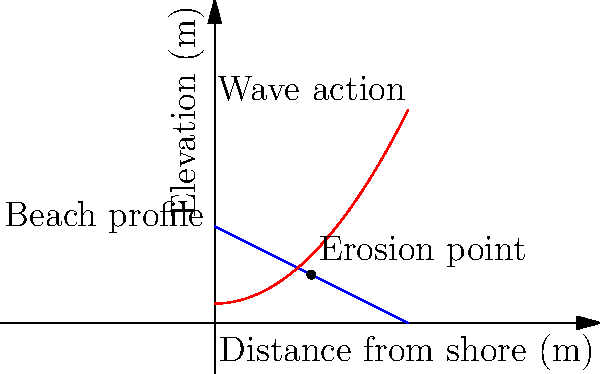As a backpacker exploring Ibiza's hidden beaches, you notice a particular sandy beach experiencing erosion. The beach profile can be approximated by the function $h(x) = 5 - 0.5x$, where $h$ is the elevation in meters and $x$ is the distance from the shore in meters. The wave action can be described by the function $w(x) = 1 + 0.1x^2$. At what distance from the shore does the maximum erosion occur, and what is the erosion rate at this point if the coefficient of erosion is $0.02 \text{ m}^3/\text{year}$ per meter of elevation difference? To solve this problem, we'll follow these steps:

1) The point of maximum erosion occurs where the difference between the beach profile and wave action is greatest.

2) We can find this by equating the derivatives of both functions:

   $\frac{d}{dx}h(x) = -0.5$
   $\frac{d}{dx}w(x) = 0.2x$

3) Equating these:
   $-0.5 = 0.2x$
   $x = -\frac{0.5}{0.2} = -2.5$

4) However, x cannot be negative in this context, so we need to find the point of intersection:

   $5 - 0.5x = 1 + 0.1x^2$
   $4 - 0.5x = 0.1x^2$
   $0.1x^2 + 0.5x - 4 = 0$

5) Solving this quadratic equation:
   $x = \frac{-0.5 \pm \sqrt{0.25 + 1.6}}{0.2} = \frac{-0.5 \pm 1.34}{0.2}$

   The positive solution is $x \approx 5$ meters.

6) At this point, the elevation difference is:
   $h(5) - w(5) = (5 - 0.5*5) - (1 + 0.1*5^2) = 2.5 - 3.5 = -1$ meter

7) The erosion rate is thus:
   $0.02 \text{ m}^3/\text{year} * |-1 \text{ m}| = 0.02 \text{ m}^3/\text{year}$

Therefore, the maximum erosion occurs 5 meters from the shore, with an erosion rate of 0.02 m³/year.
Answer: 5 m from shore; 0.02 m³/year 